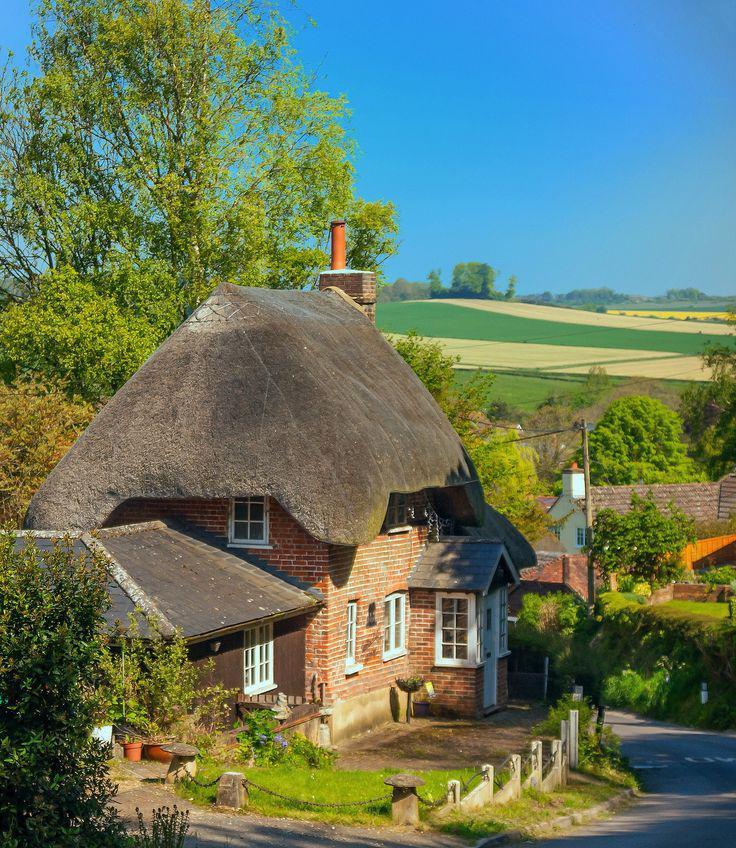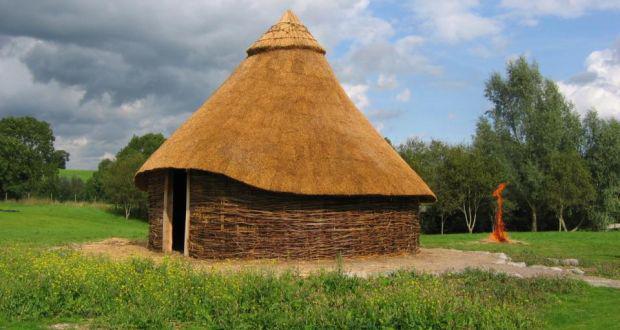The first image is the image on the left, the second image is the image on the right. Examine the images to the left and right. Is the description "The left and right image contains a total of two home." accurate? Answer yes or no. Yes. The first image is the image on the left, the second image is the image on the right. Evaluate the accuracy of this statement regarding the images: "The right image features a building with a roof featuring an inverted cone-shape with gray Xs on it, over arch windows that are above an arch door.". Is it true? Answer yes or no. No. 